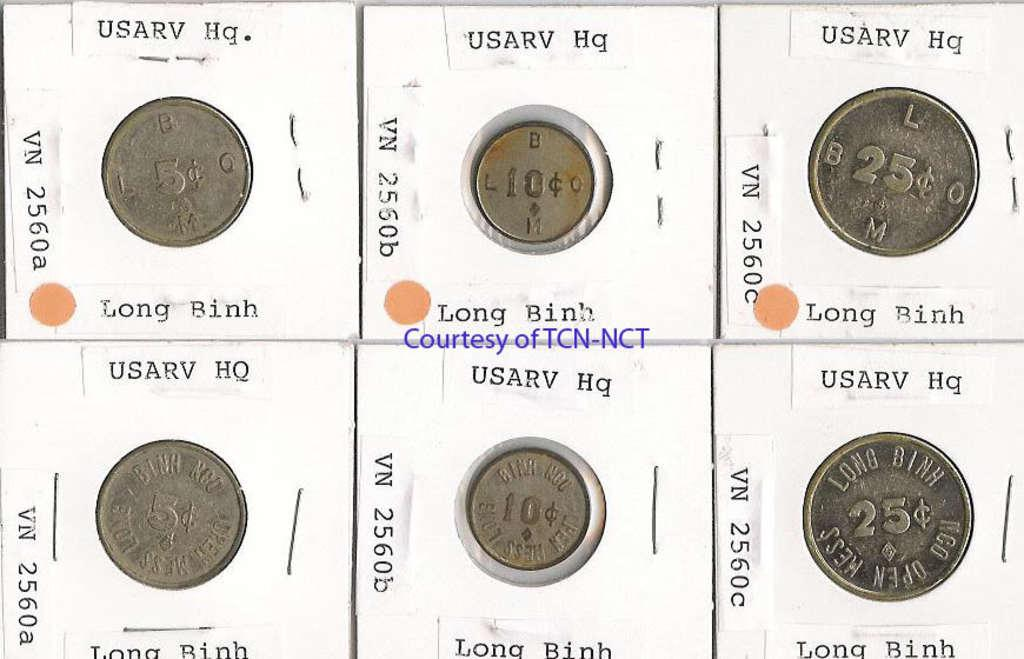What objects can be seen in the image? There are coins in the image. What else is present in the image besides the coins? There is text in the image. What committee is responsible for the motion observed in the image? There is no committee or motion present in the image; it only contains coins and text. 